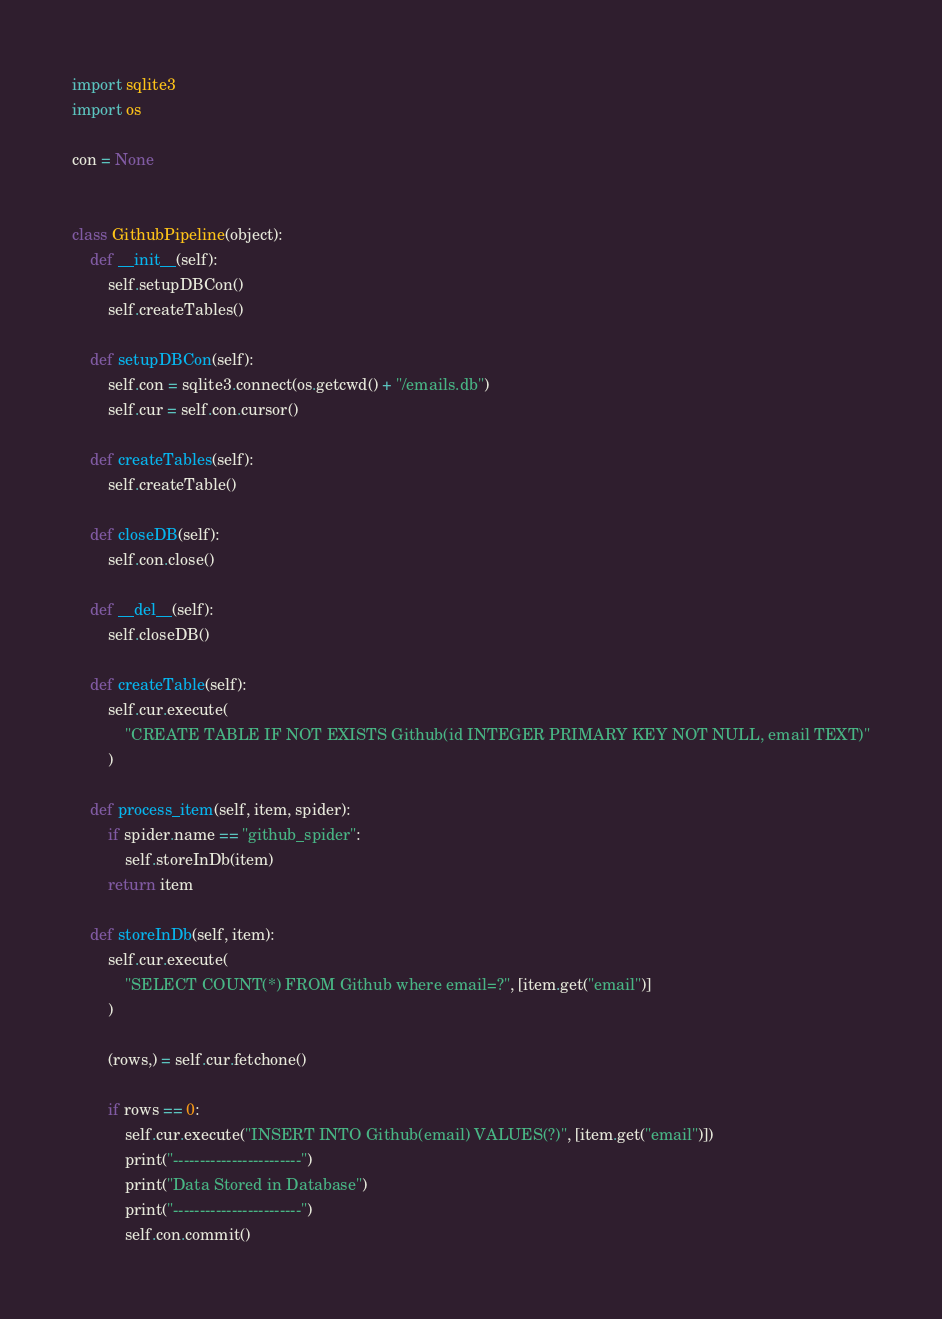Convert code to text. <code><loc_0><loc_0><loc_500><loc_500><_Python_>import sqlite3
import os

con = None


class GithubPipeline(object):
    def __init__(self):
        self.setupDBCon()
        self.createTables()

    def setupDBCon(self):
        self.con = sqlite3.connect(os.getcwd() + "/emails.db")
        self.cur = self.con.cursor()

    def createTables(self):
        self.createTable()

    def closeDB(self):
        self.con.close()

    def __del__(self):
        self.closeDB()

    def createTable(self):
        self.cur.execute(
            "CREATE TABLE IF NOT EXISTS Github(id INTEGER PRIMARY KEY NOT NULL, email TEXT)"
        )

    def process_item(self, item, spider):
        if spider.name == "github_spider":
            self.storeInDb(item)
        return item

    def storeInDb(self, item):
        self.cur.execute(
            "SELECT COUNT(*) FROM Github where email=?", [item.get("email")]
        )

        (rows,) = self.cur.fetchone()

        if rows == 0:
            self.cur.execute("INSERT INTO Github(email) VALUES(?)", [item.get("email")])
            print("------------------------")
            print("Data Stored in Database")
            print("------------------------")
            self.con.commit()
</code> 